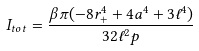<formula> <loc_0><loc_0><loc_500><loc_500>I _ { t o t } = \frac { \beta \pi ( - 8 r _ { + } ^ { 4 } + 4 a ^ { 4 } + 3 \ell ^ { 4 } ) } { 3 2 \ell ^ { 2 } p }</formula> 